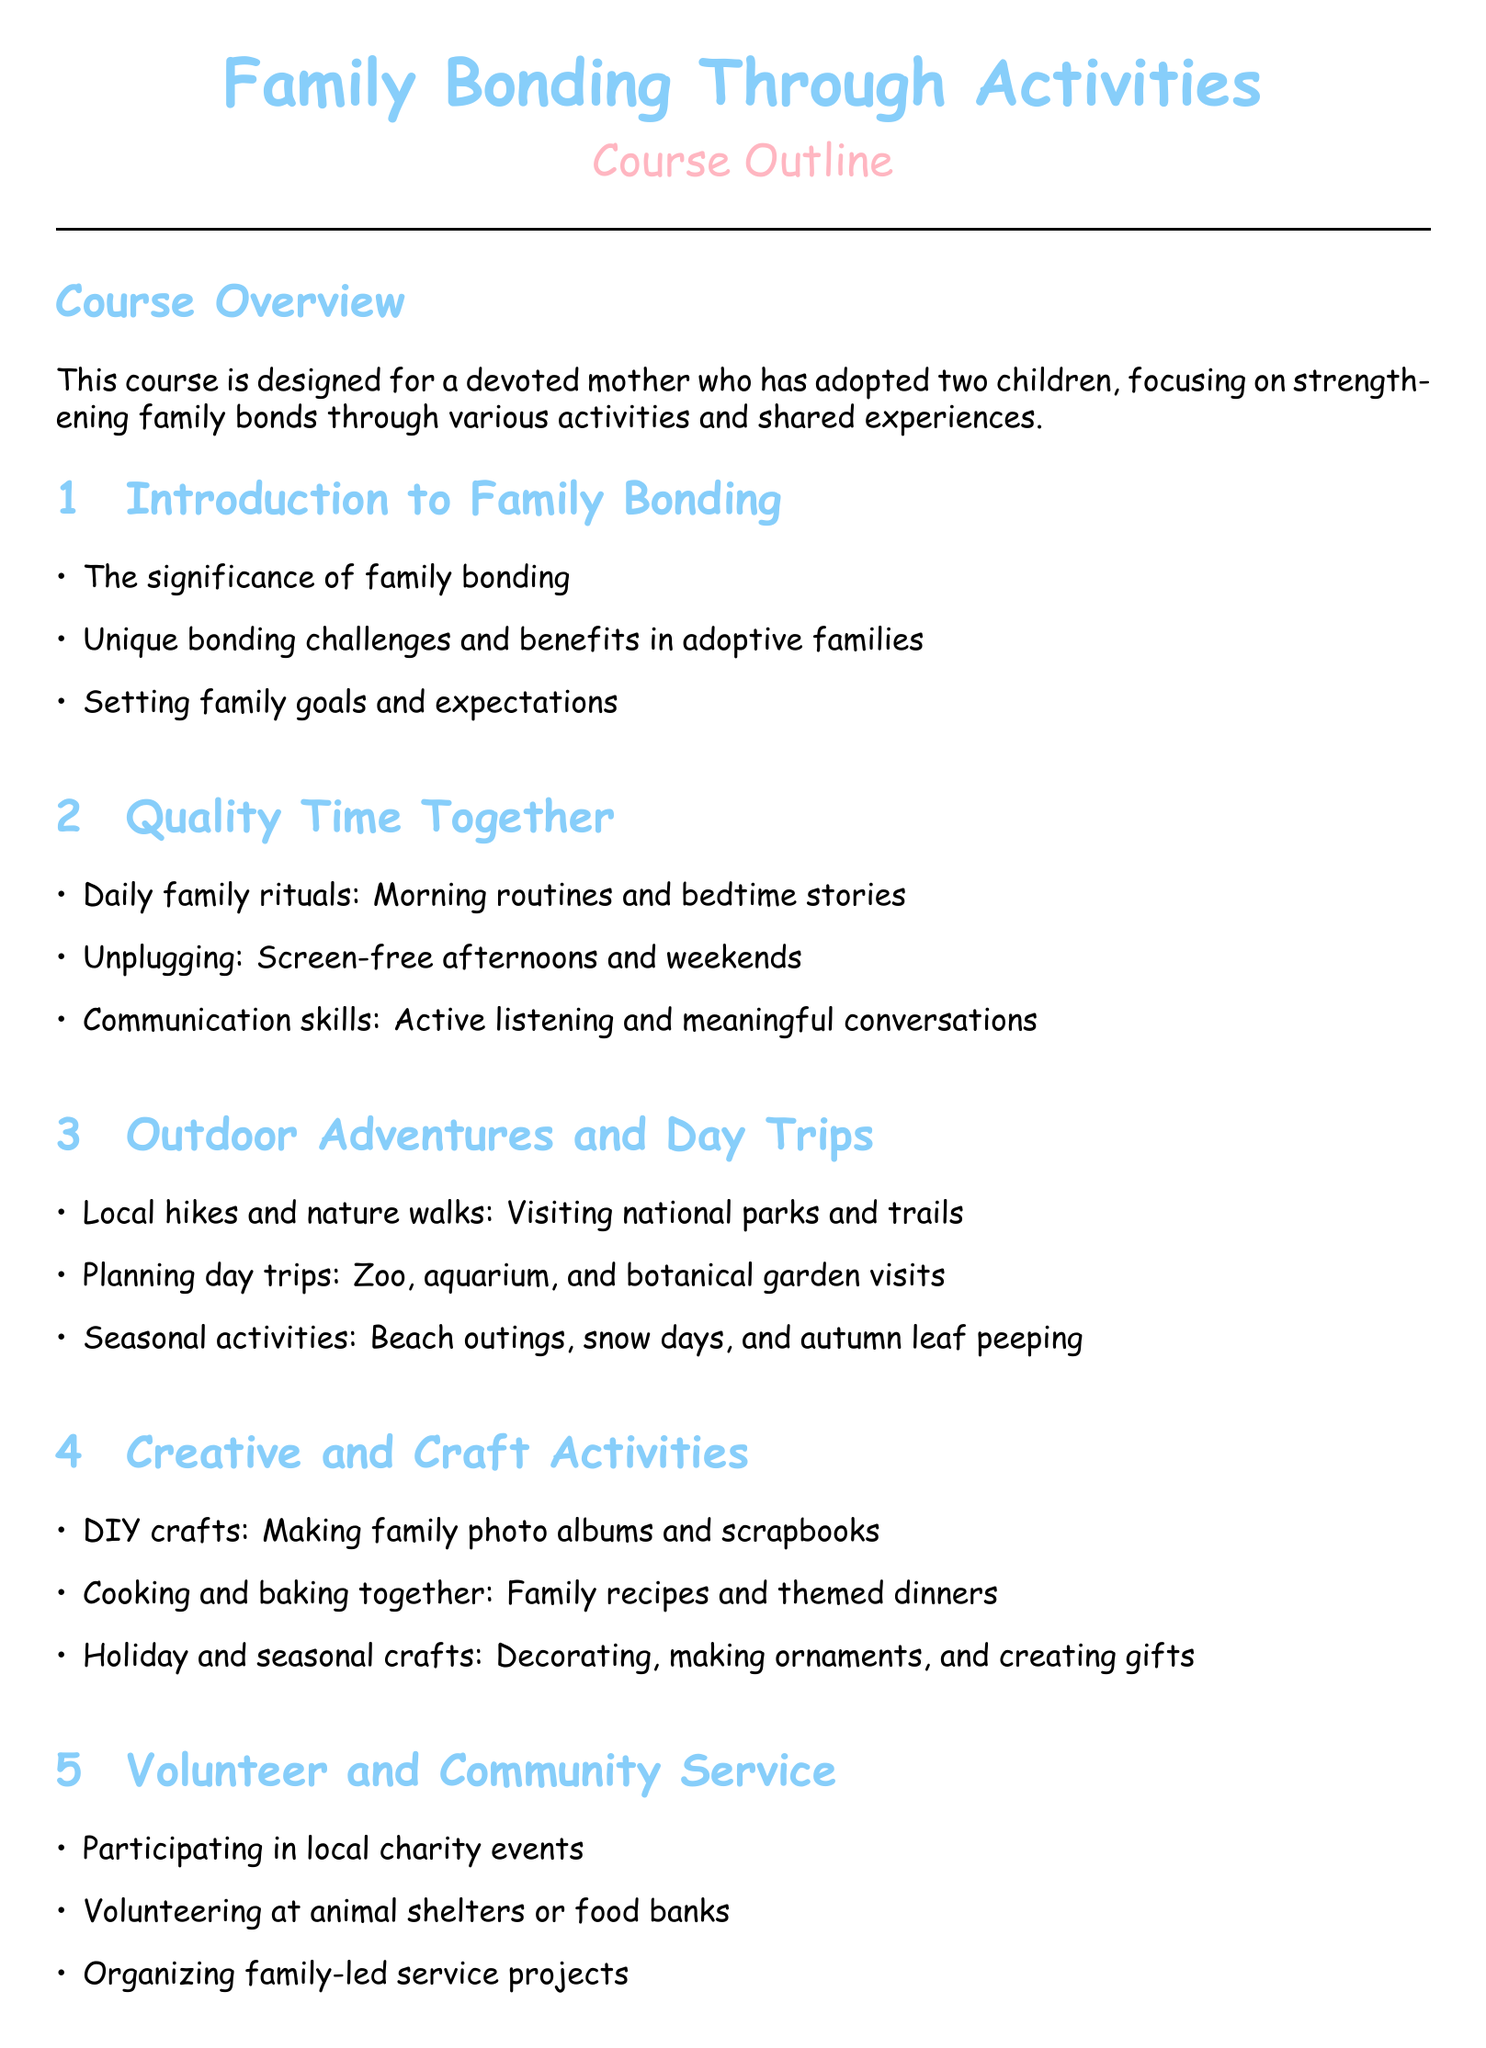What is the title of the course? The title of the course is listed at the top of the document and is "Family Bonding Through Activities."
Answer: Family Bonding Through Activities Who is the target audience for the course? The target audience is mentioned in the course overview, identifying a specific type of participant.
Answer: A devoted mother who has adopted two children What is one example of a daily family ritual described? Daily family rituals are outlined in the section on Quality Time Together, providing specific examples of activities.
Answer: Morning routines Name one outdoor activity suggested in the syllabus. The Outdoor Adventures and Day Trips section lists various activities, including specific outings for families.
Answer: Local hikes What are two types of creative activities mentioned in the document? The Creative and Craft Activities section lists various crafts and creative projects suitable for families.
Answer: DIY crafts and Cooking How many sections are there in total in the syllabus? The document outlines the structure of the course with distinct sections, and by counting them, we find the total.
Answer: Six What is the purpose of the Volunteer and Community Service section? The purpose is described within the section itself, outlining how the activities contribute to family bonding.
Answer: Encourage family bonding through service What is the conclusion of the course? The conclusion summarizes the overall goal of the course, highlighting key takeaways in the final section.
Answer: Strengthen family bonds and enjoy cherished moments together 